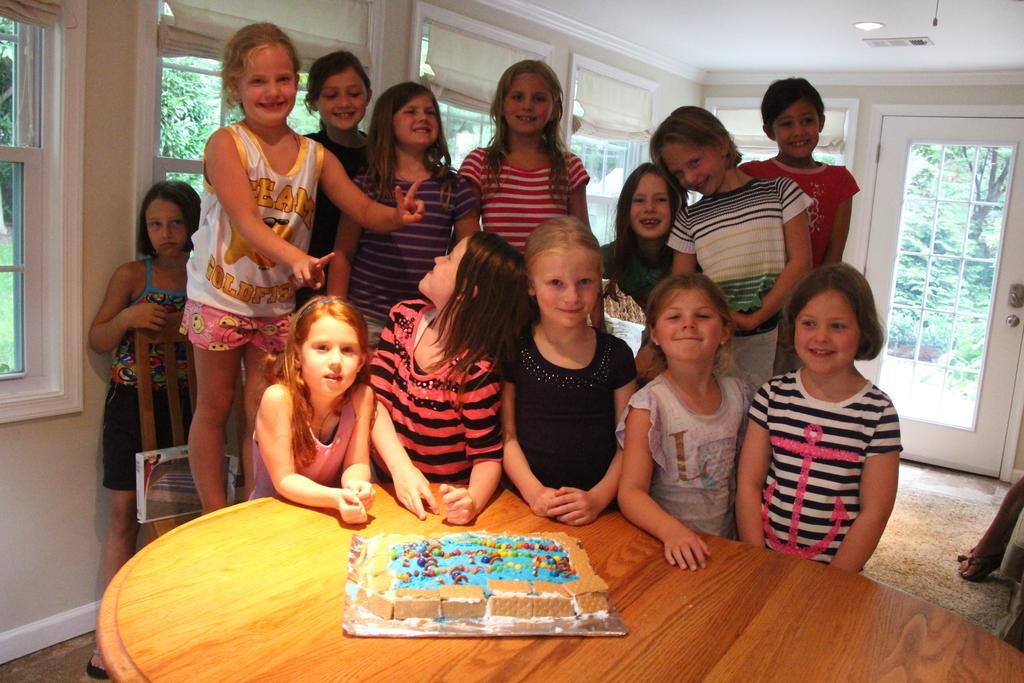Can you describe this image briefly? In this image I can see the group of people standing. In front of them there is a cake on the table. Backside of them there is a window glass. From the window I can see some of the trees. 